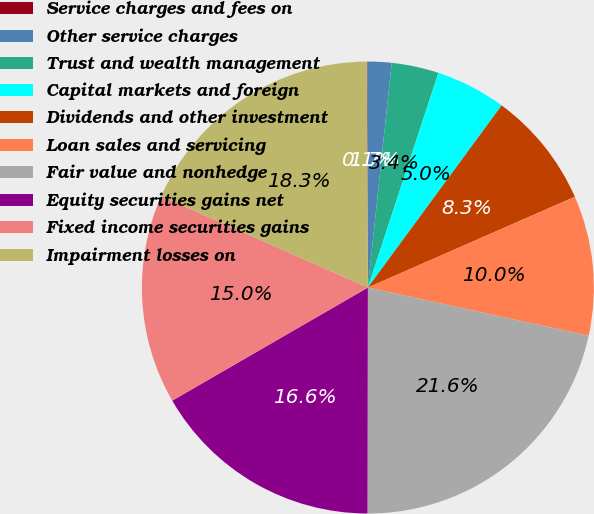Convert chart to OTSL. <chart><loc_0><loc_0><loc_500><loc_500><pie_chart><fcel>Service charges and fees on<fcel>Other service charges<fcel>Trust and wealth management<fcel>Capital markets and foreign<fcel>Dividends and other investment<fcel>Loan sales and servicing<fcel>Fair value and nonhedge<fcel>Equity securities gains net<fcel>Fixed income securities gains<fcel>Impairment losses on<nl><fcel>0.05%<fcel>1.71%<fcel>3.37%<fcel>5.03%<fcel>8.34%<fcel>10.0%<fcel>21.6%<fcel>16.63%<fcel>14.97%<fcel>18.29%<nl></chart> 